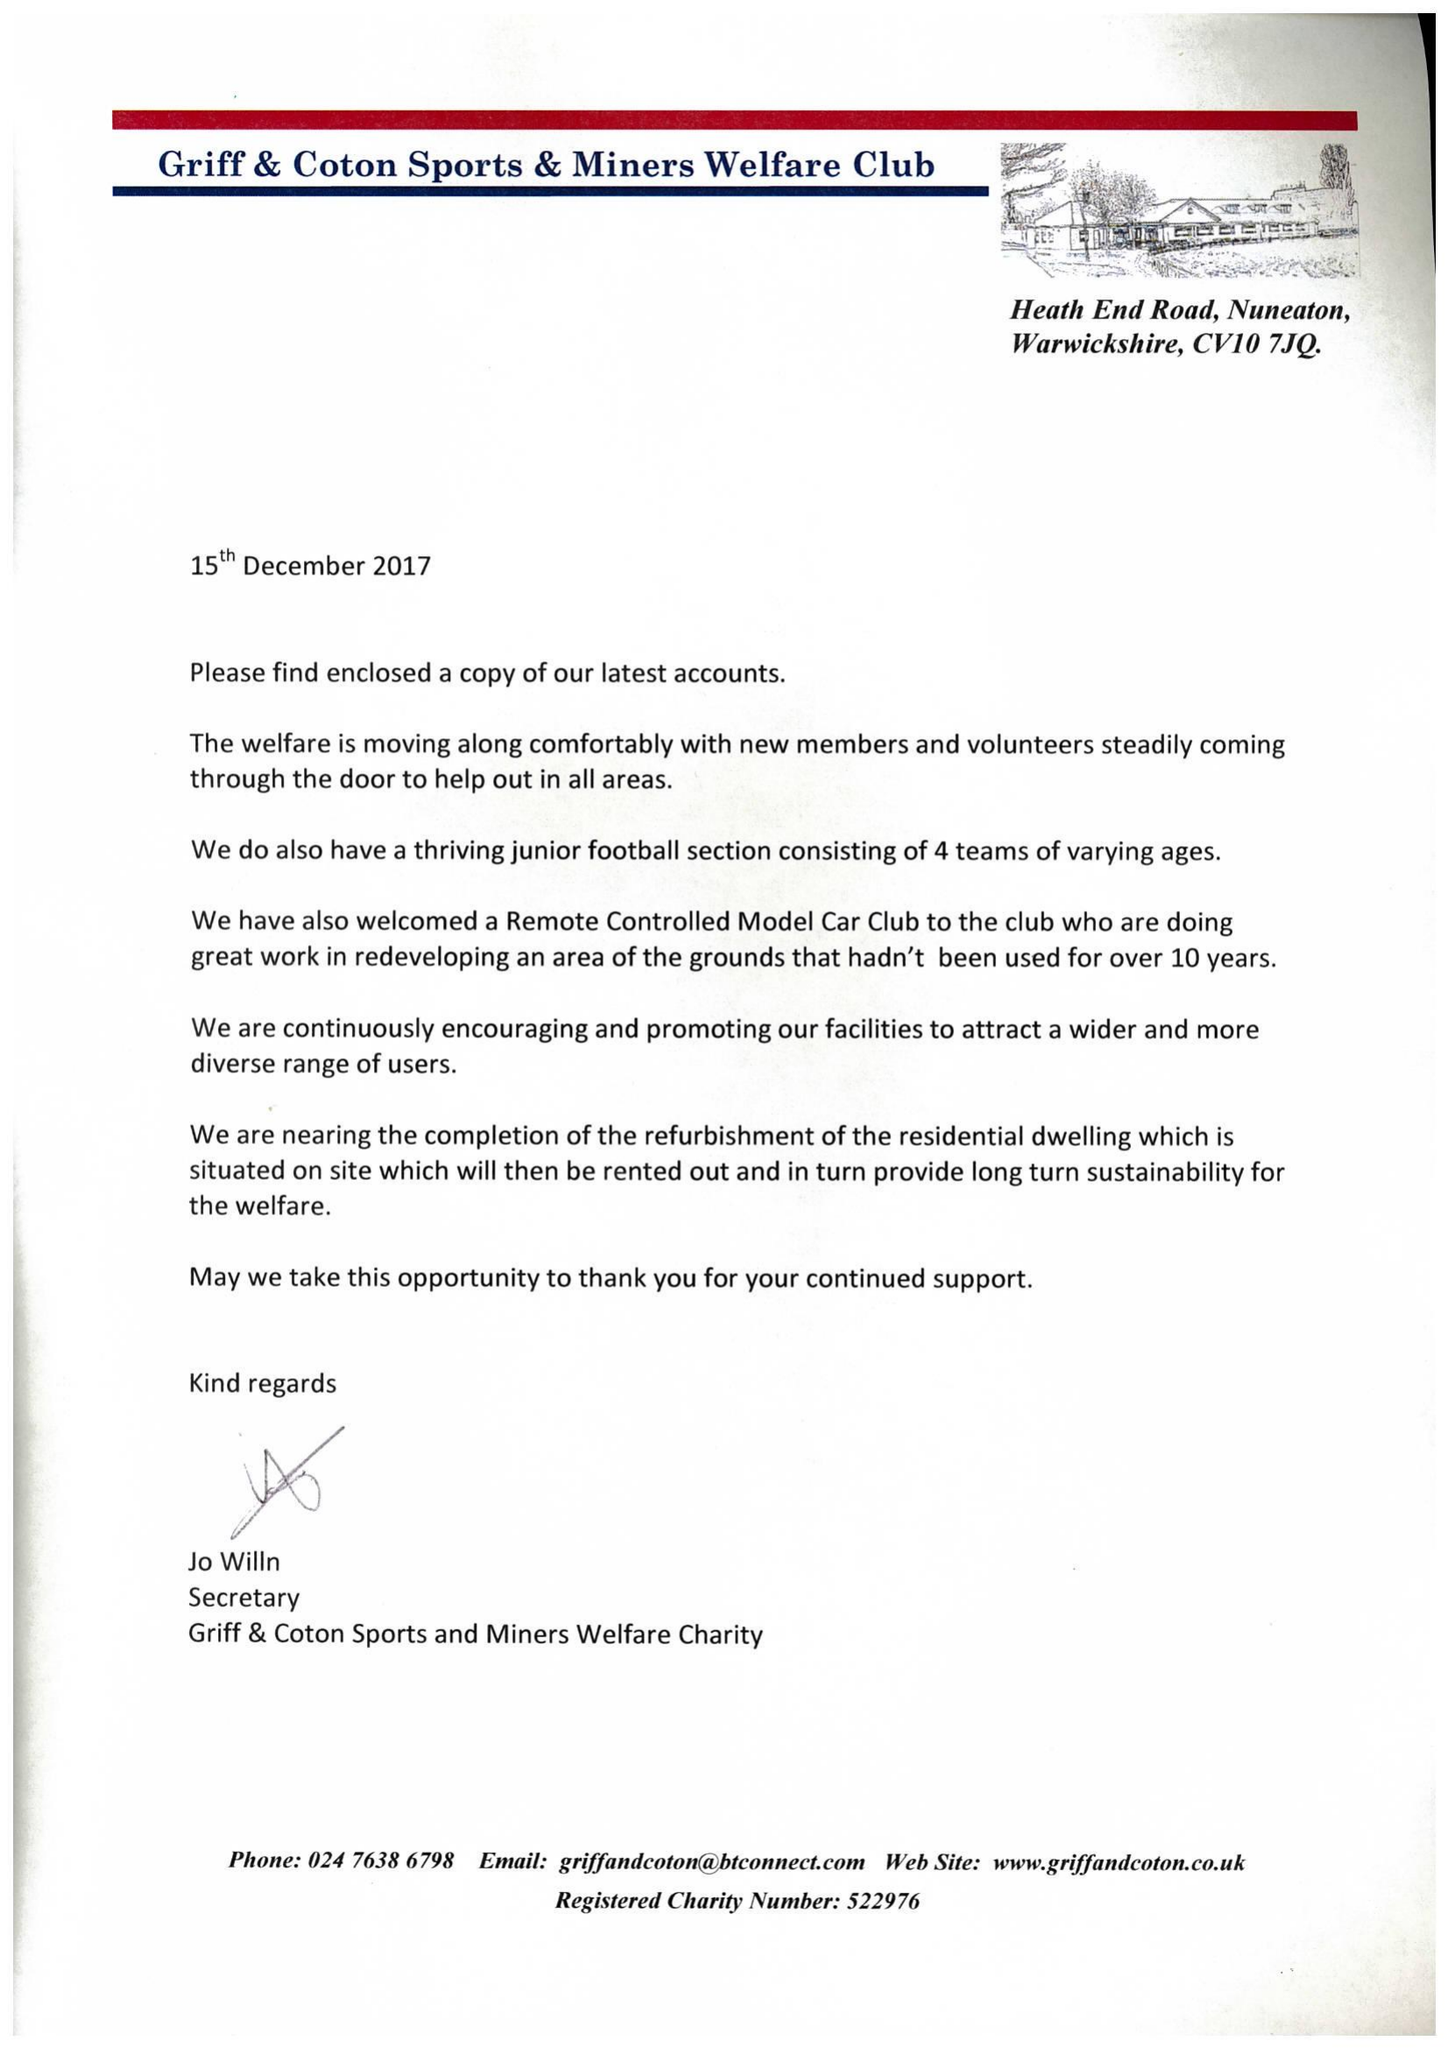What is the value for the charity_name?
Answer the question using a single word or phrase. Griff and Coton Sports and Miners Welfare Charity 